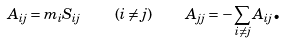<formula> <loc_0><loc_0><loc_500><loc_500>A _ { i j } = m _ { i } S _ { i j } \quad ( i \neq j ) \quad A _ { j j } = - \sum _ { i \neq j } A _ { i j } \text {.}</formula> 